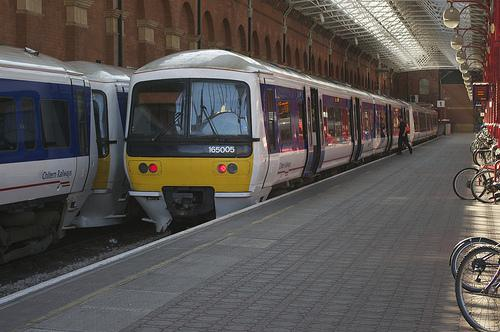Question: what is on the bottom right?
Choices:
A. Tennis racket.
B. Skateboard.
C. Baseball bat.
D. Bicycle wheels.
Answer with the letter. Answer: D Question: how many people are shown?
Choices:
A. Two.
B. One.
C. Three.
D. Four.
Answer with the letter. Answer: B Question: who is getting on the train?
Choices:
A. Person.
B. Passenger.
C. Traveler.
D. Commuter.
Answer with the letter. Answer: A Question: why is the man getting on the train?
Choices:
A. Visiting.
B. Sightseeing.
C. Train buff.
D. Transportation.
Answer with the letter. Answer: D 